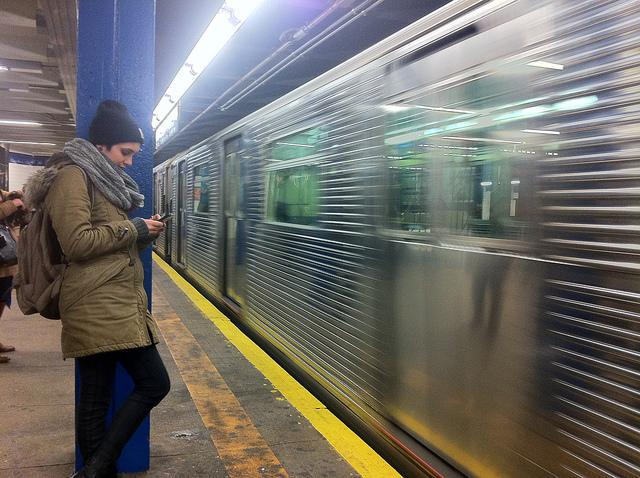The person next to the train looks like who? woman 